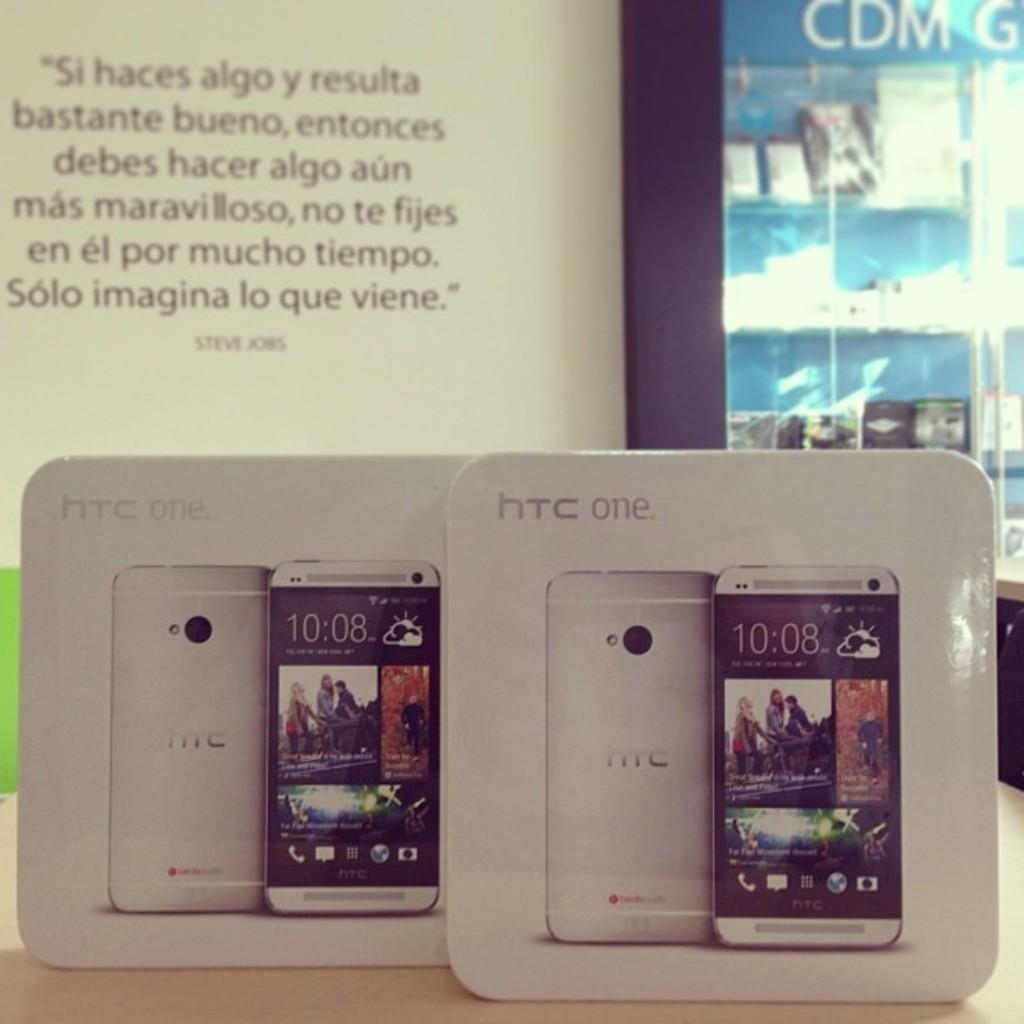<image>
Present a compact description of the photo's key features. A couple of packages of hTc one phones with the phones inside 